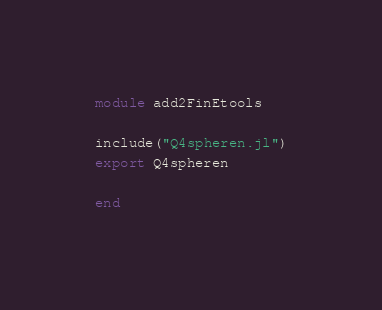<code> <loc_0><loc_0><loc_500><loc_500><_Julia_>module add2FinEtools

include("Q4spheren.jl")
export Q4spheren

end
</code> 